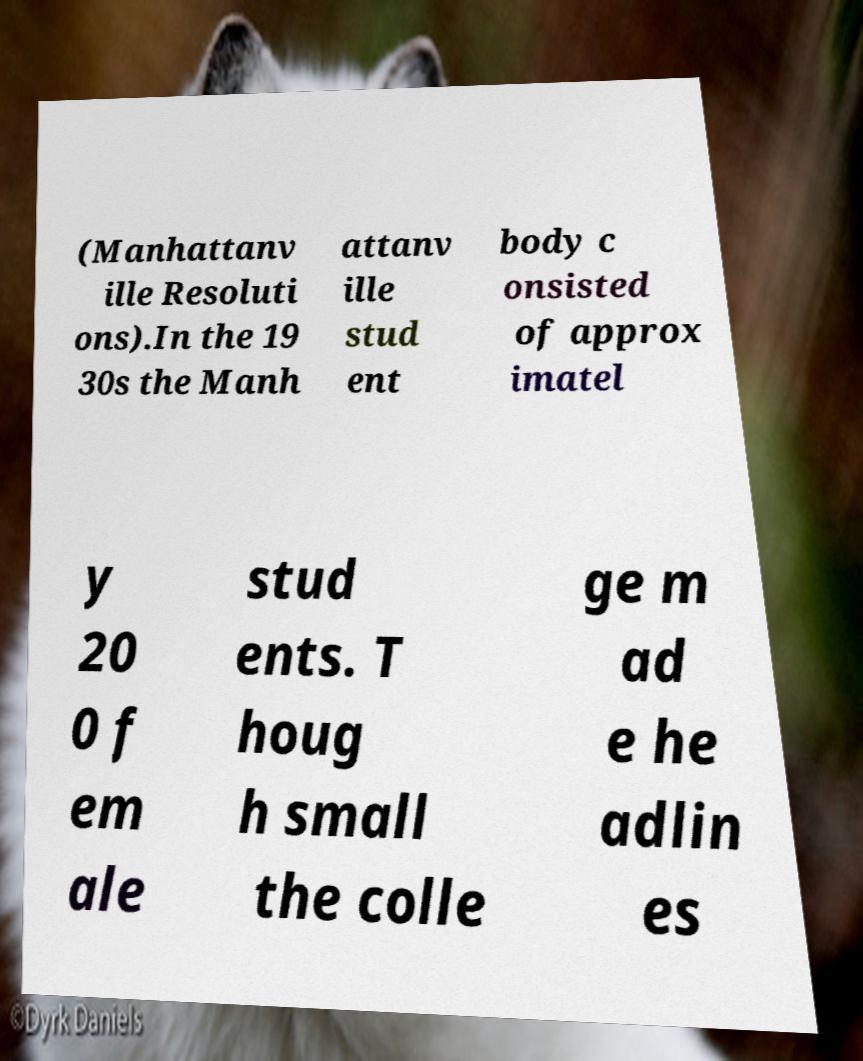For documentation purposes, I need the text within this image transcribed. Could you provide that? (Manhattanv ille Resoluti ons).In the 19 30s the Manh attanv ille stud ent body c onsisted of approx imatel y 20 0 f em ale stud ents. T houg h small the colle ge m ad e he adlin es 